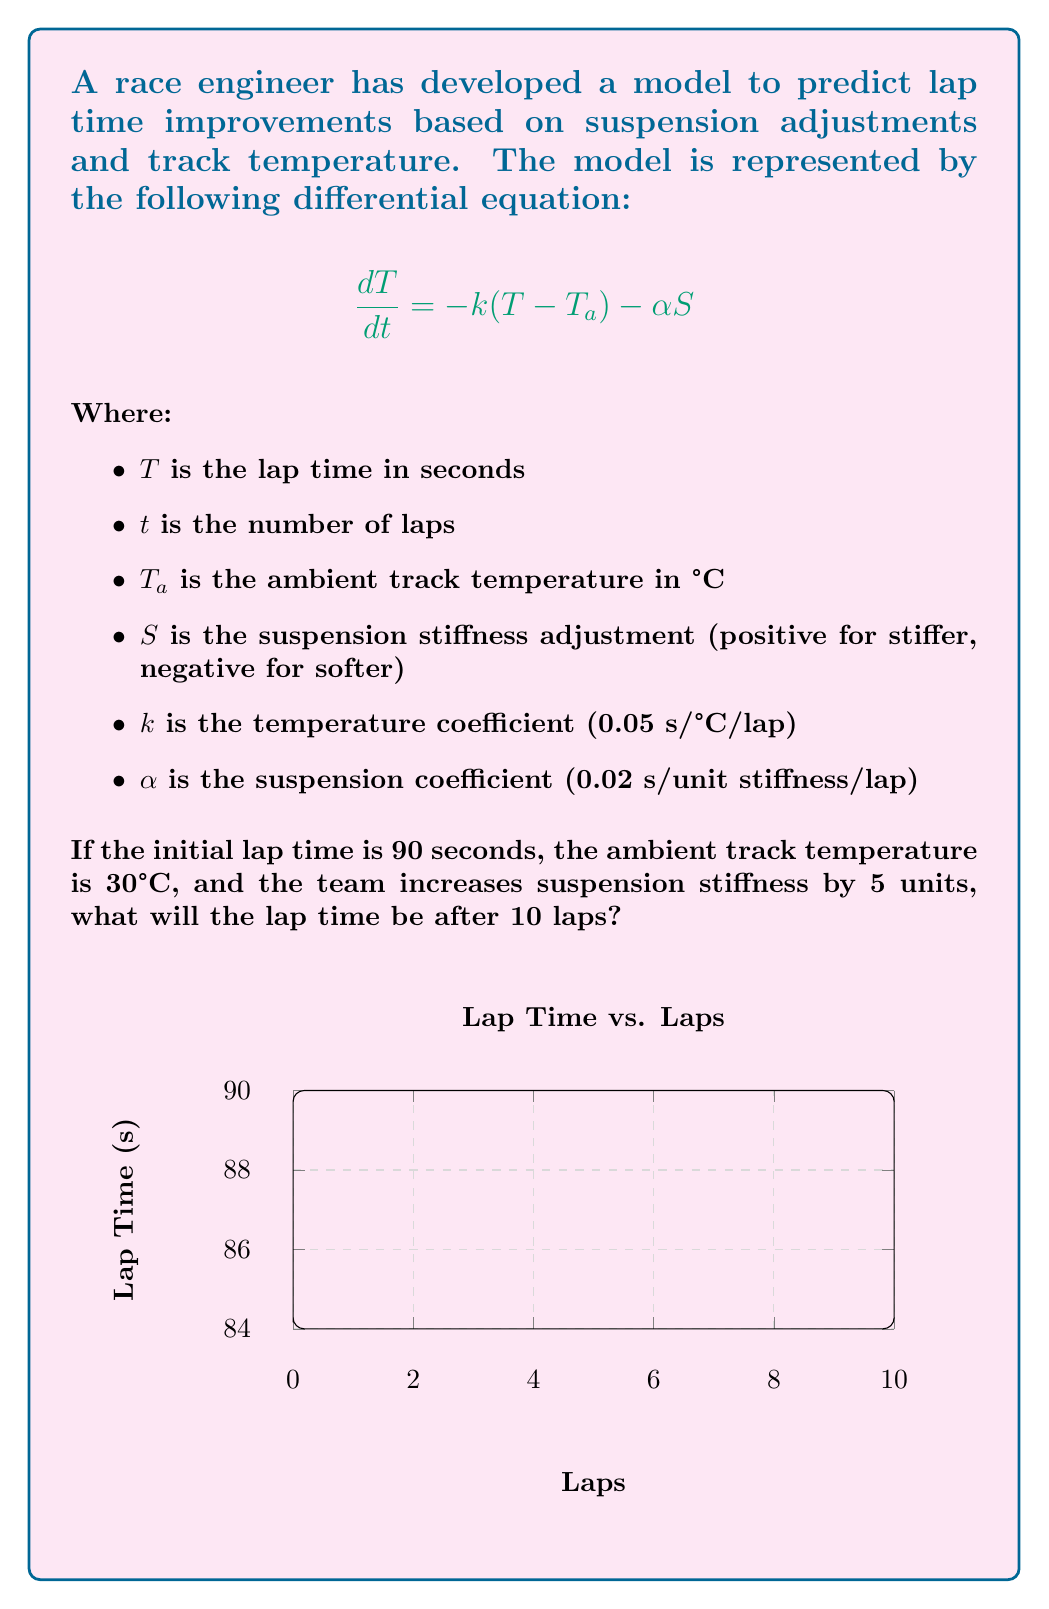What is the answer to this math problem? To solve this problem, we need to follow these steps:

1) First, we need to solve the differential equation. The general solution for this type of first-order linear differential equation is:

   $$T(t) = Ce^{-kt} + T_a - \frac{\alpha S}{k}$$

   Where $C$ is a constant we need to determine from the initial conditions.

2) We're given that the initial lap time $T(0) = 90$ seconds. Let's use this to find $C$:

   $$90 = C + 30 - \frac{0.02 \cdot 5}{0.05} = C + 30 - 2$$
   $$C = 62$$

3) Now we have our full solution:

   $$T(t) = 62e^{-0.05t} + 30 - 2$$

4) To find the lap time after 10 laps, we simply plug in $t = 10$:

   $$T(10) = 62e^{-0.05 \cdot 10} + 30 - 2$$
   $$= 62e^{-0.5} + 28$$
   $$\approx 62 \cdot 0.6065 + 28$$
   $$\approx 37.603 + 28$$
   $$\approx 65.603$$

5) Therefore, after 10 laps, the predicted lap time will be approximately 65.603 seconds.
Answer: 65.603 seconds 